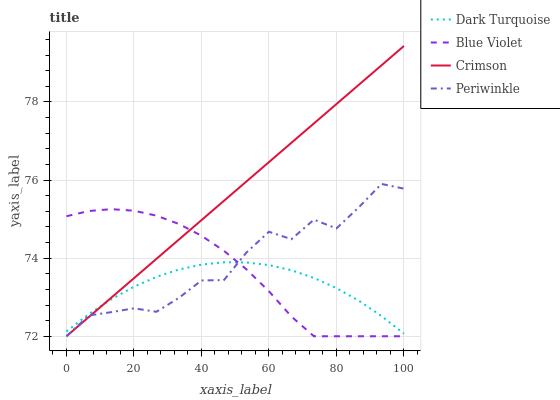Does Dark Turquoise have the minimum area under the curve?
Answer yes or no. Yes. Does Crimson have the maximum area under the curve?
Answer yes or no. Yes. Does Periwinkle have the minimum area under the curve?
Answer yes or no. No. Does Periwinkle have the maximum area under the curve?
Answer yes or no. No. Is Crimson the smoothest?
Answer yes or no. Yes. Is Periwinkle the roughest?
Answer yes or no. Yes. Is Dark Turquoise the smoothest?
Answer yes or no. No. Is Dark Turquoise the roughest?
Answer yes or no. No. Does Dark Turquoise have the lowest value?
Answer yes or no. No. Does Crimson have the highest value?
Answer yes or no. Yes. Does Periwinkle have the highest value?
Answer yes or no. No. 